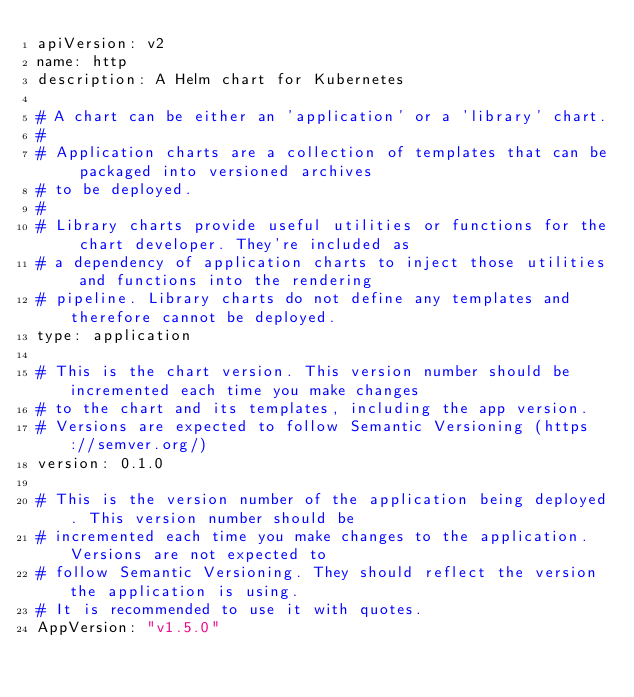<code> <loc_0><loc_0><loc_500><loc_500><_YAML_>apiVersion: v2
name: http
description: A Helm chart for Kubernetes

# A chart can be either an 'application' or a 'library' chart.
#
# Application charts are a collection of templates that can be packaged into versioned archives
# to be deployed.
#
# Library charts provide useful utilities or functions for the chart developer. They're included as
# a dependency of application charts to inject those utilities and functions into the rendering
# pipeline. Library charts do not define any templates and therefore cannot be deployed.
type: application

# This is the chart version. This version number should be incremented each time you make changes
# to the chart and its templates, including the app version.
# Versions are expected to follow Semantic Versioning (https://semver.org/)
version: 0.1.0

# This is the version number of the application being deployed. This version number should be
# incremented each time you make changes to the application. Versions are not expected to
# follow Semantic Versioning. They should reflect the version the application is using.
# It is recommended to use it with quotes.
AppVersion: "v1.5.0"
</code> 